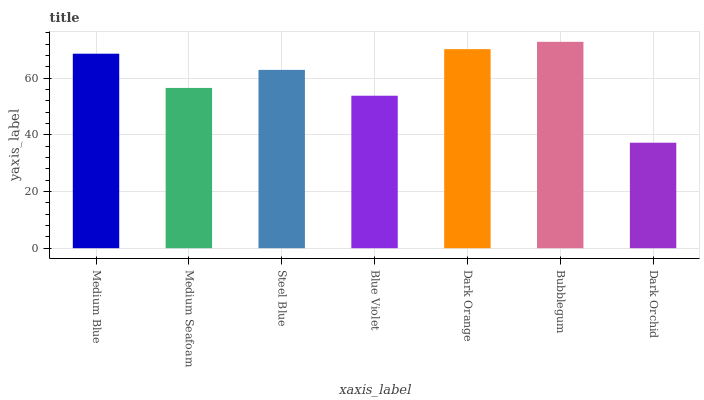Is Medium Seafoam the minimum?
Answer yes or no. No. Is Medium Seafoam the maximum?
Answer yes or no. No. Is Medium Blue greater than Medium Seafoam?
Answer yes or no. Yes. Is Medium Seafoam less than Medium Blue?
Answer yes or no. Yes. Is Medium Seafoam greater than Medium Blue?
Answer yes or no. No. Is Medium Blue less than Medium Seafoam?
Answer yes or no. No. Is Steel Blue the high median?
Answer yes or no. Yes. Is Steel Blue the low median?
Answer yes or no. Yes. Is Dark Orange the high median?
Answer yes or no. No. Is Blue Violet the low median?
Answer yes or no. No. 